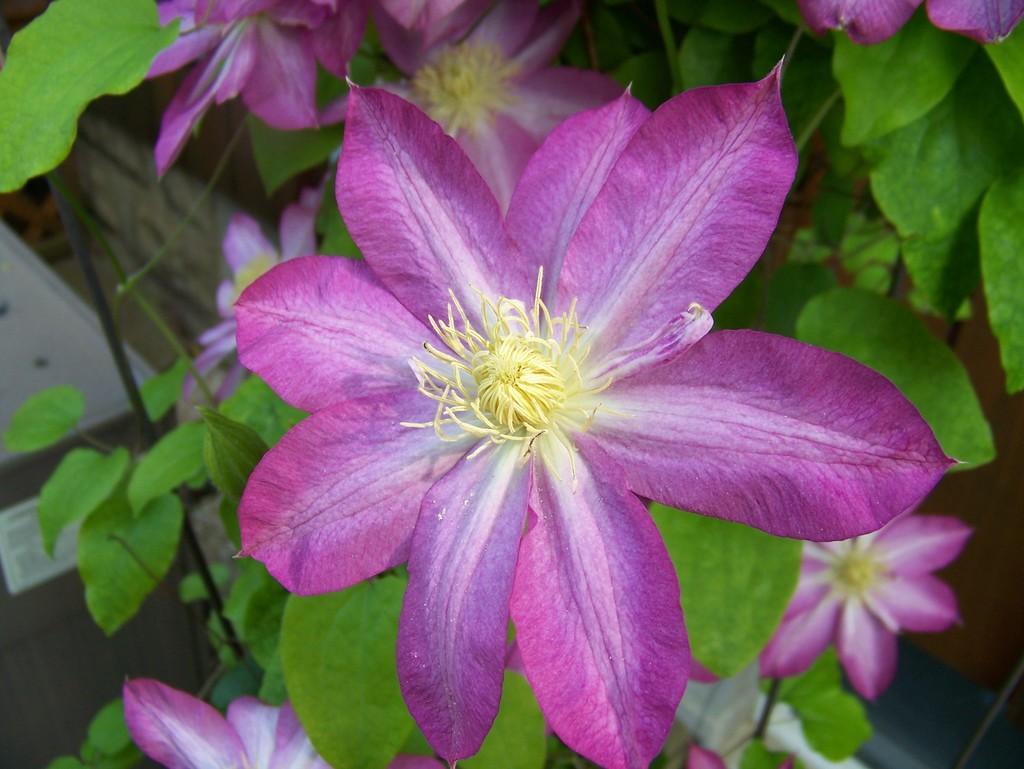In one or two sentences, can you explain what this image depicts? In the picture I can see the purple color flower of a plant. The background of the image is slightly blurred, where we can see a few more purple color flowers. 